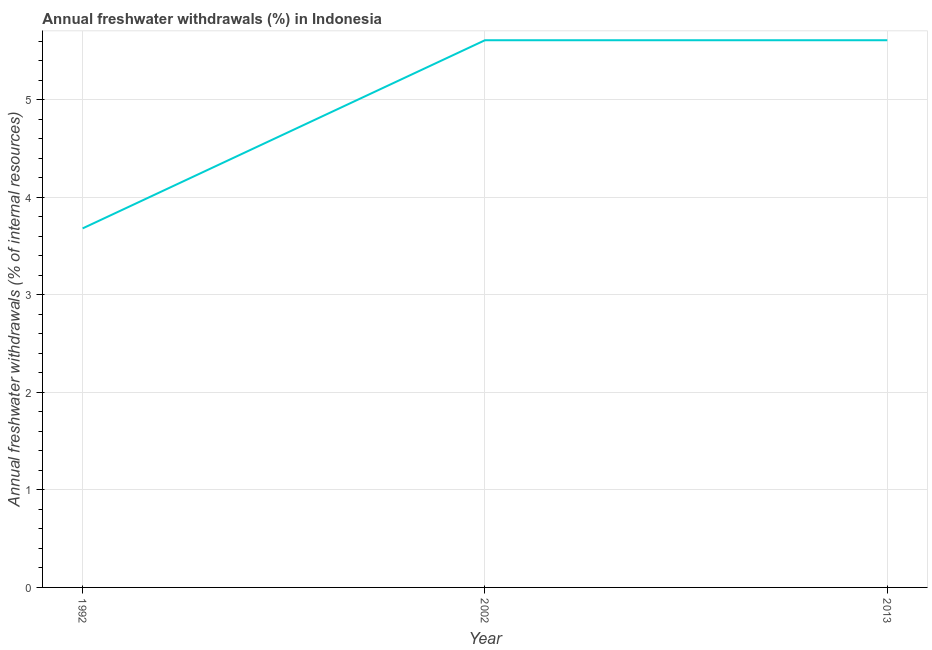What is the annual freshwater withdrawals in 2002?
Keep it short and to the point. 5.61. Across all years, what is the maximum annual freshwater withdrawals?
Make the answer very short. 5.61. Across all years, what is the minimum annual freshwater withdrawals?
Your answer should be compact. 3.68. What is the sum of the annual freshwater withdrawals?
Provide a short and direct response. 14.91. What is the difference between the annual freshwater withdrawals in 1992 and 2002?
Keep it short and to the point. -1.93. What is the average annual freshwater withdrawals per year?
Your answer should be very brief. 4.97. What is the median annual freshwater withdrawals?
Provide a short and direct response. 5.61. Do a majority of the years between 2013 and 2002 (inclusive) have annual freshwater withdrawals greater than 2.6 %?
Ensure brevity in your answer.  No. Is the annual freshwater withdrawals in 1992 less than that in 2002?
Provide a short and direct response. Yes. What is the difference between the highest and the second highest annual freshwater withdrawals?
Provide a short and direct response. 0. Is the sum of the annual freshwater withdrawals in 1992 and 2013 greater than the maximum annual freshwater withdrawals across all years?
Provide a short and direct response. Yes. What is the difference between the highest and the lowest annual freshwater withdrawals?
Your answer should be very brief. 1.93. In how many years, is the annual freshwater withdrawals greater than the average annual freshwater withdrawals taken over all years?
Keep it short and to the point. 2. Does the annual freshwater withdrawals monotonically increase over the years?
Ensure brevity in your answer.  No. Does the graph contain any zero values?
Provide a succinct answer. No. What is the title of the graph?
Offer a very short reply. Annual freshwater withdrawals (%) in Indonesia. What is the label or title of the Y-axis?
Your answer should be very brief. Annual freshwater withdrawals (% of internal resources). What is the Annual freshwater withdrawals (% of internal resources) in 1992?
Your response must be concise. 3.68. What is the Annual freshwater withdrawals (% of internal resources) in 2002?
Provide a short and direct response. 5.61. What is the Annual freshwater withdrawals (% of internal resources) of 2013?
Provide a succinct answer. 5.61. What is the difference between the Annual freshwater withdrawals (% of internal resources) in 1992 and 2002?
Your response must be concise. -1.93. What is the difference between the Annual freshwater withdrawals (% of internal resources) in 1992 and 2013?
Give a very brief answer. -1.93. What is the difference between the Annual freshwater withdrawals (% of internal resources) in 2002 and 2013?
Your answer should be very brief. 0. What is the ratio of the Annual freshwater withdrawals (% of internal resources) in 1992 to that in 2002?
Make the answer very short. 0.66. What is the ratio of the Annual freshwater withdrawals (% of internal resources) in 1992 to that in 2013?
Your answer should be very brief. 0.66. What is the ratio of the Annual freshwater withdrawals (% of internal resources) in 2002 to that in 2013?
Your answer should be compact. 1. 